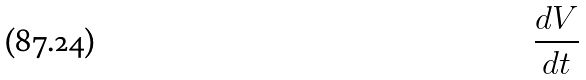<formula> <loc_0><loc_0><loc_500><loc_500>\frac { d V } { d t }</formula> 